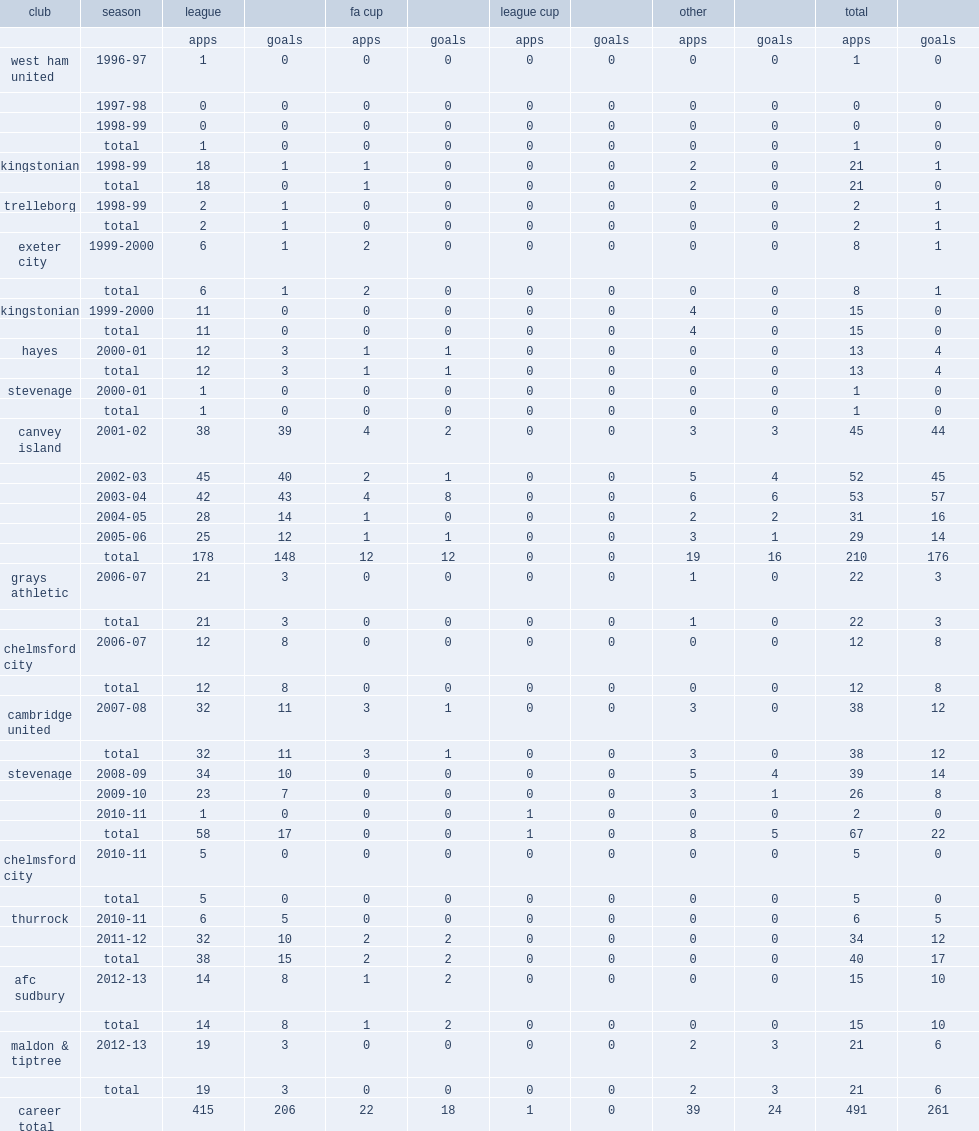In the 2001-02 season, how many games did lee boylan join canvey island, playing for the club during his five-year tenure? 210.0. In the 2001-02 season, how many goals did lee boylan join canvey island, playing for the club during his five-year tenure? 176.0. 